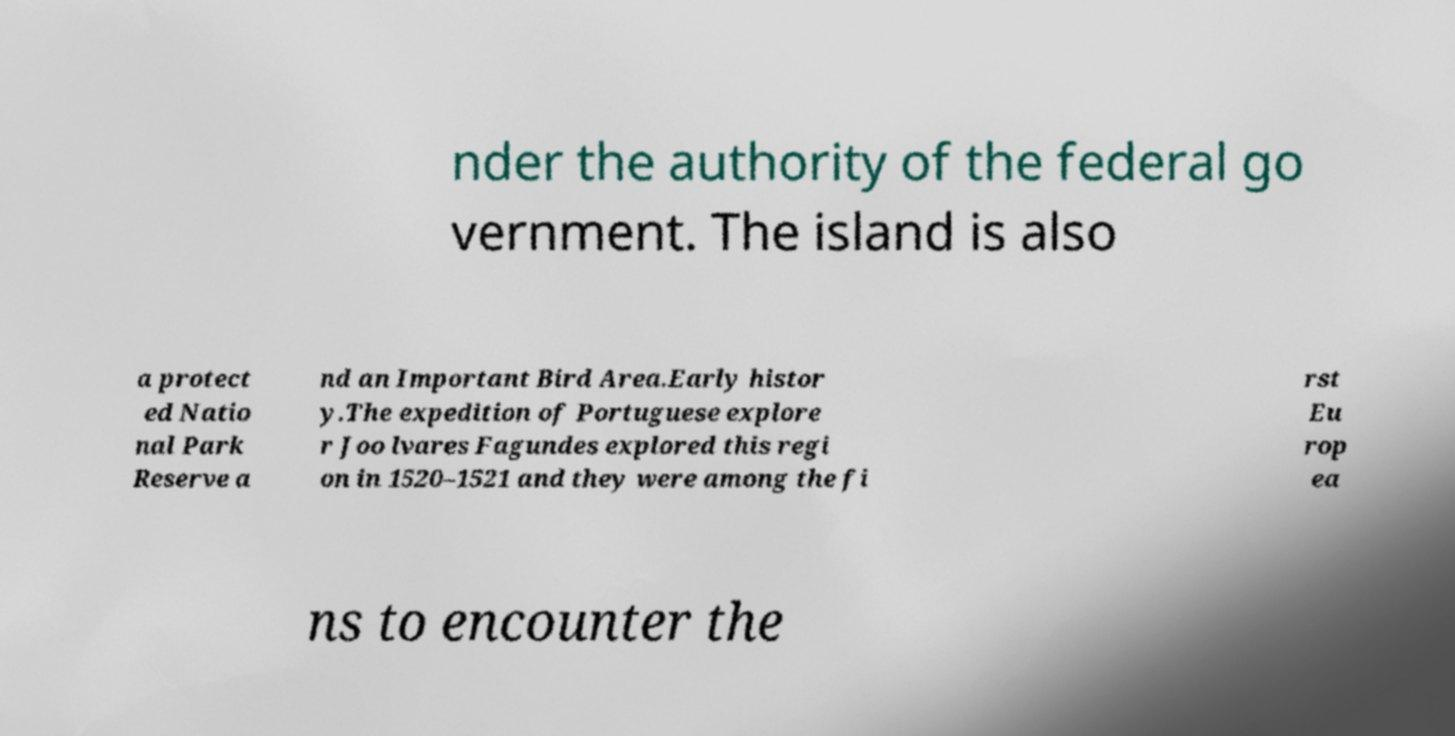What messages or text are displayed in this image? I need them in a readable, typed format. nder the authority of the federal go vernment. The island is also a protect ed Natio nal Park Reserve a nd an Important Bird Area.Early histor y.The expedition of Portuguese explore r Joo lvares Fagundes explored this regi on in 1520–1521 and they were among the fi rst Eu rop ea ns to encounter the 